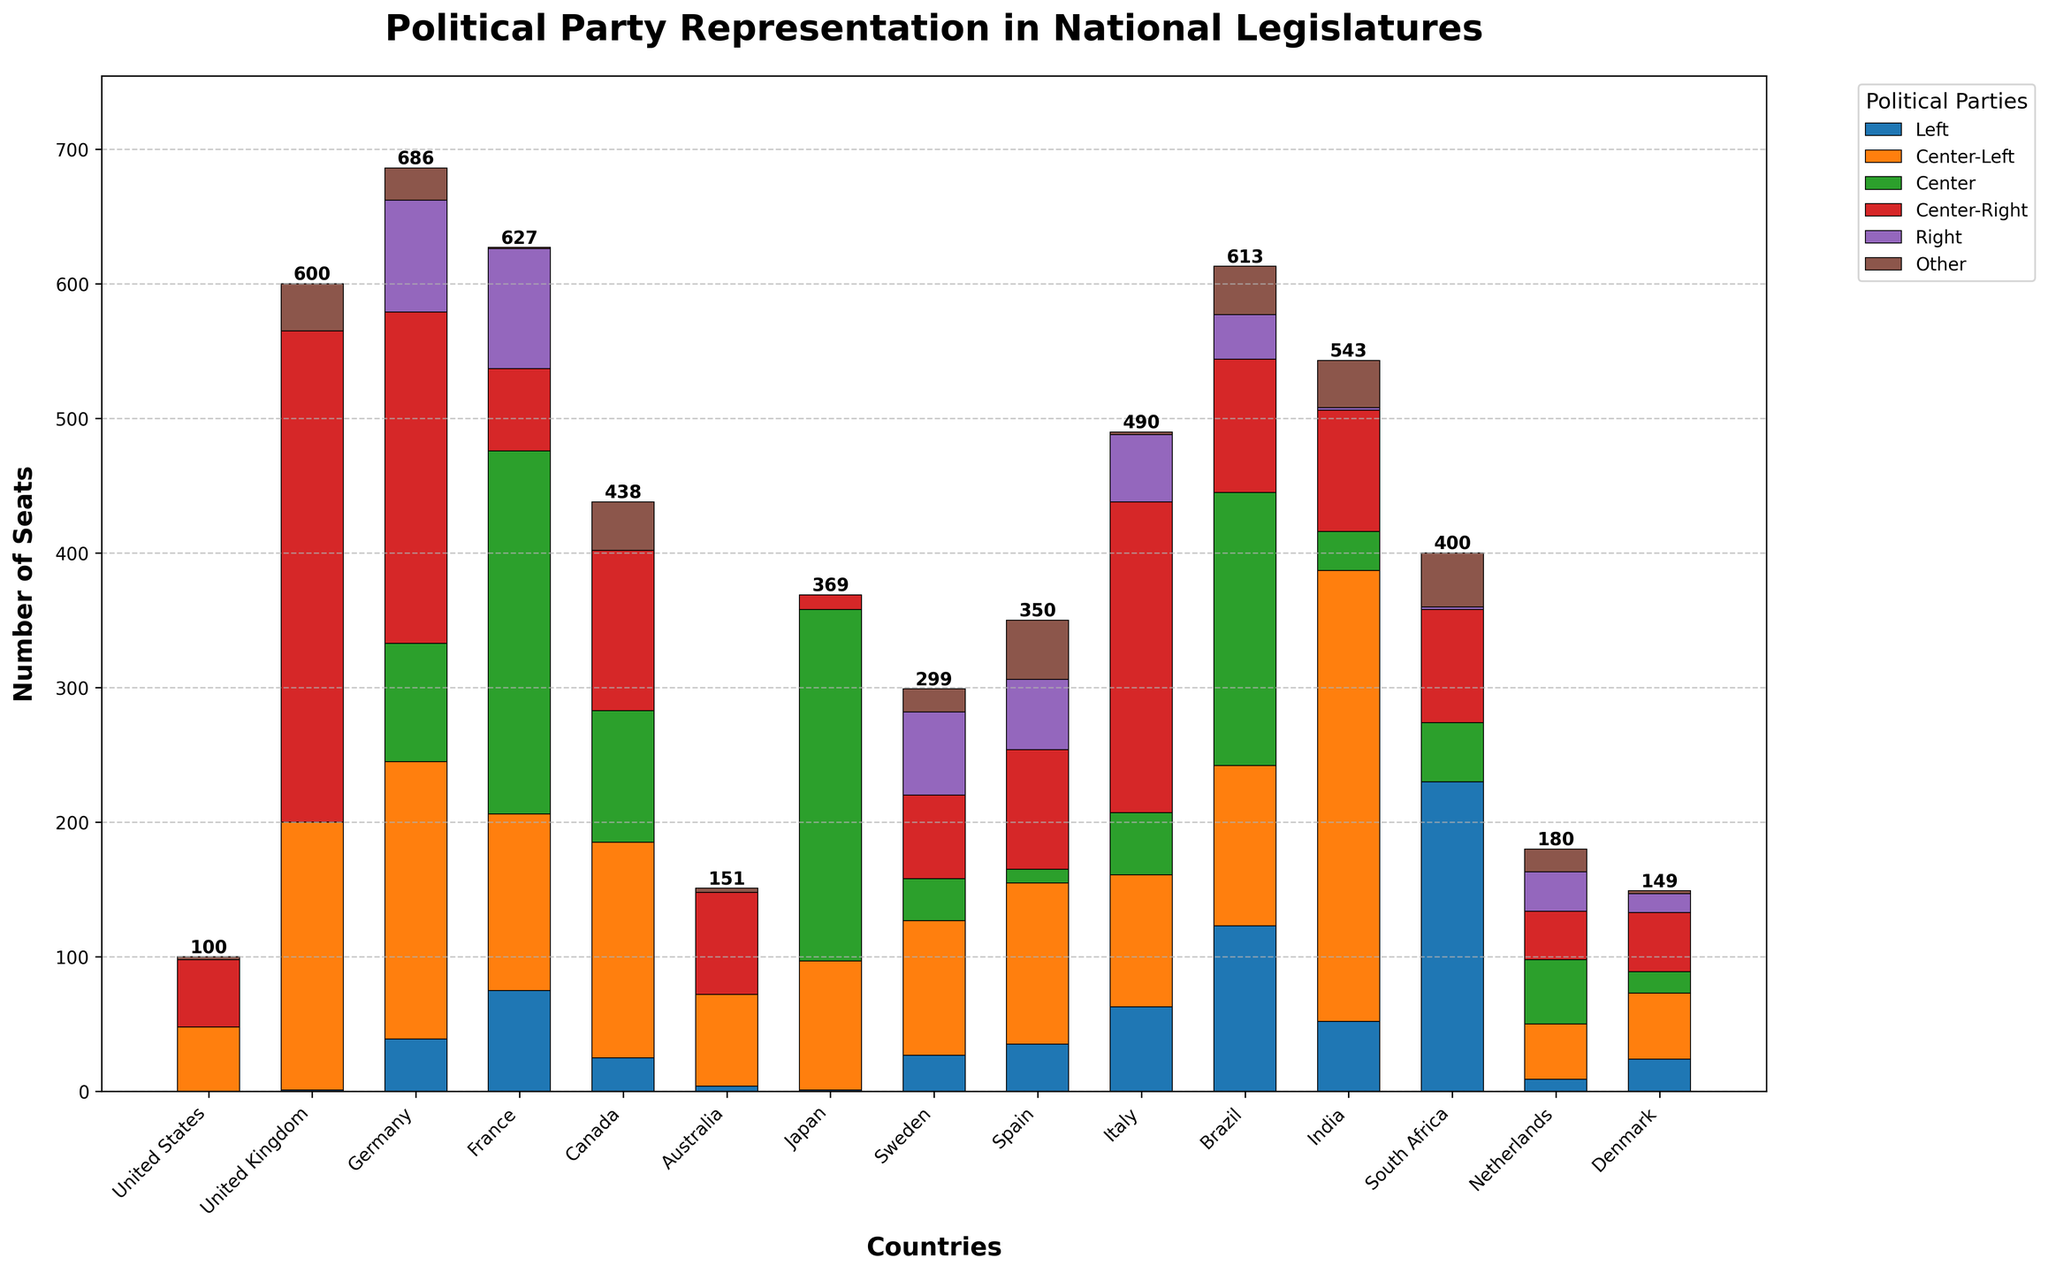What is the composition of the national legislature in the United States in terms of political parties? The bar representing the United States shows 48 seats for Center-Left, 50 seats for Center-Right, and 2 seats for Other.
Answer: 48 Center-Left, 50 Center-Right, 2 Other Which country has the highest representation of Left parties? The bar representing South Africa shows the highest number of seats for Left parties among all countries, with 230 seats.
Answer: South Africa Compare the representation of Center-Right parties in Germany and Italy. Which country has more, and by how many seats? Germany has 246 seats for Center-Right parties, while Italy has 231 seats. Germany has 15 more seats than Italy.
Answer: Germany, 15 What is the total number of seats for Center-Left and Center parties in France? France has 131 seats for Center-Left and 270 seats for Center. Adding these together gives 131 + 270 = 401.
Answer: 401 How does the representation of Right parties in Sweden compare to that in Spain? Sweden has 62 seats for Right parties, while Spain has 52 seats. Sweden has 10 more seats than Spain.
Answer: Sweden, 10 Which country has the smallest representation of Center parties and how many seats does it have? The United States and Australia both have 0 seats for Center parties, which is the smallest representation.
Answer: United States and Australia, 0 What is the total number of seats for all political parties combined in Canada? Adding all the seats in Canada: 25 (Left) + 160 (Center-Left) + 98 (Center) + 119 (Center-Right) + 0 (Right) + 36 (Other) = 438.
Answer: 438 What visual pattern do you observe for countries with a high number of seats for Center parties? Countries like France, Japan, and Brazil, which have high representation for the Center parties, show the tallest sections in the middle of their bars.
Answer: Tall middle sections Which country has a unique representation with no Center-Left but a significant Left party representation? South Africa has 230 seats for Left and 0 for Center-Left, indicating a unique representation.
Answer: South Africa In the United Kingdom, how does the number of Center-Right seats compare to the combined seats of Other and Center parties? The United Kingdom has 365 Center-Right seats. The combined seats for Other (35) and Center (0) are 35. Thus, Center-Right has 330 more seats.
Answer: 330 more seats 